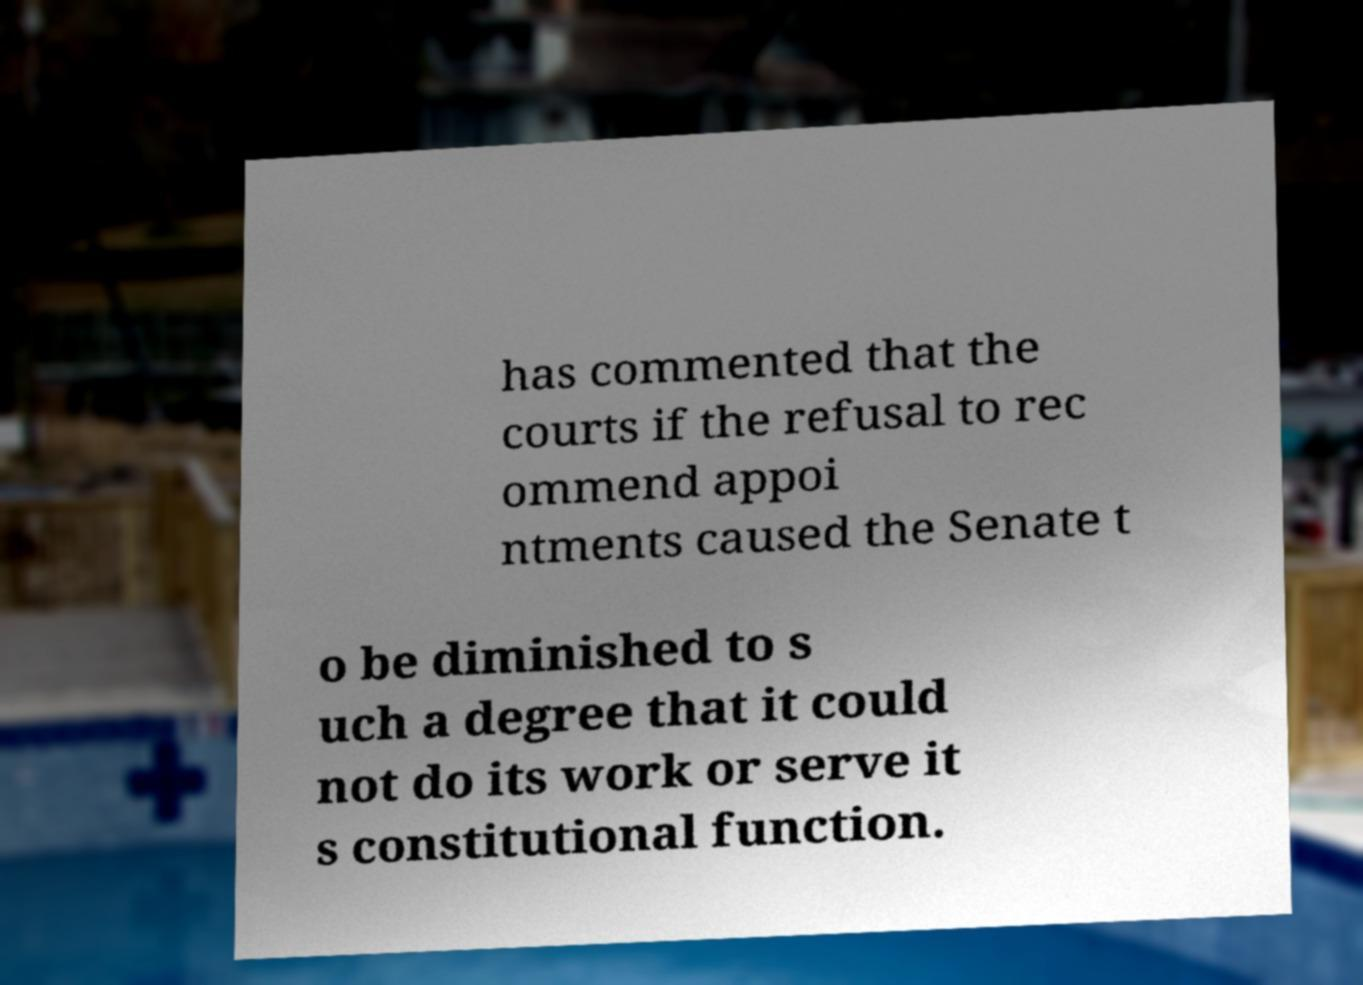Can you accurately transcribe the text from the provided image for me? has commented that the courts if the refusal to rec ommend appoi ntments caused the Senate t o be diminished to s uch a degree that it could not do its work or serve it s constitutional function. 